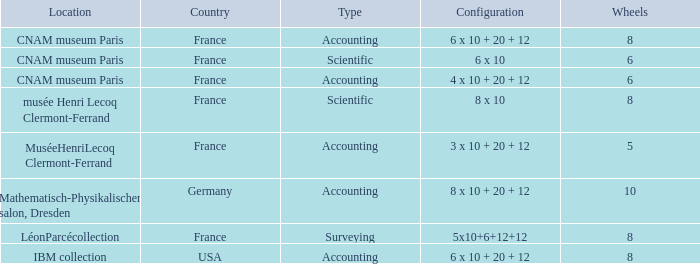What location has surveying as the type? LéonParcécollection. 